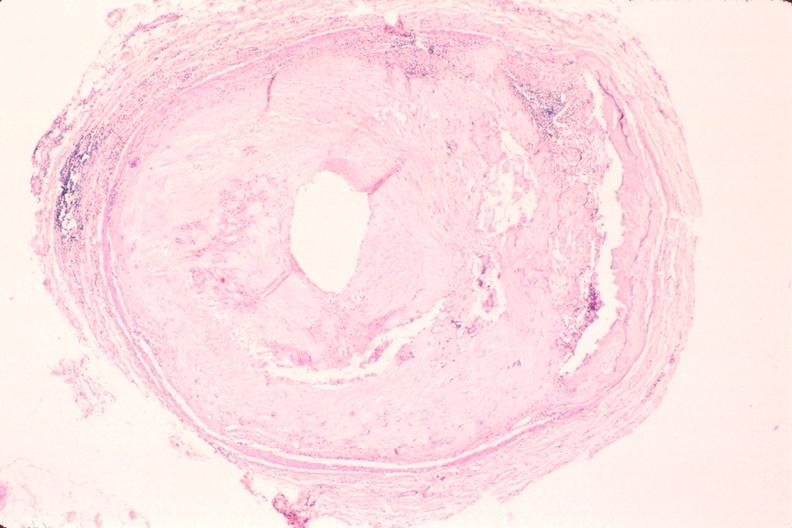where is this in?
Answer the question using a single word or phrase. In vasculature 